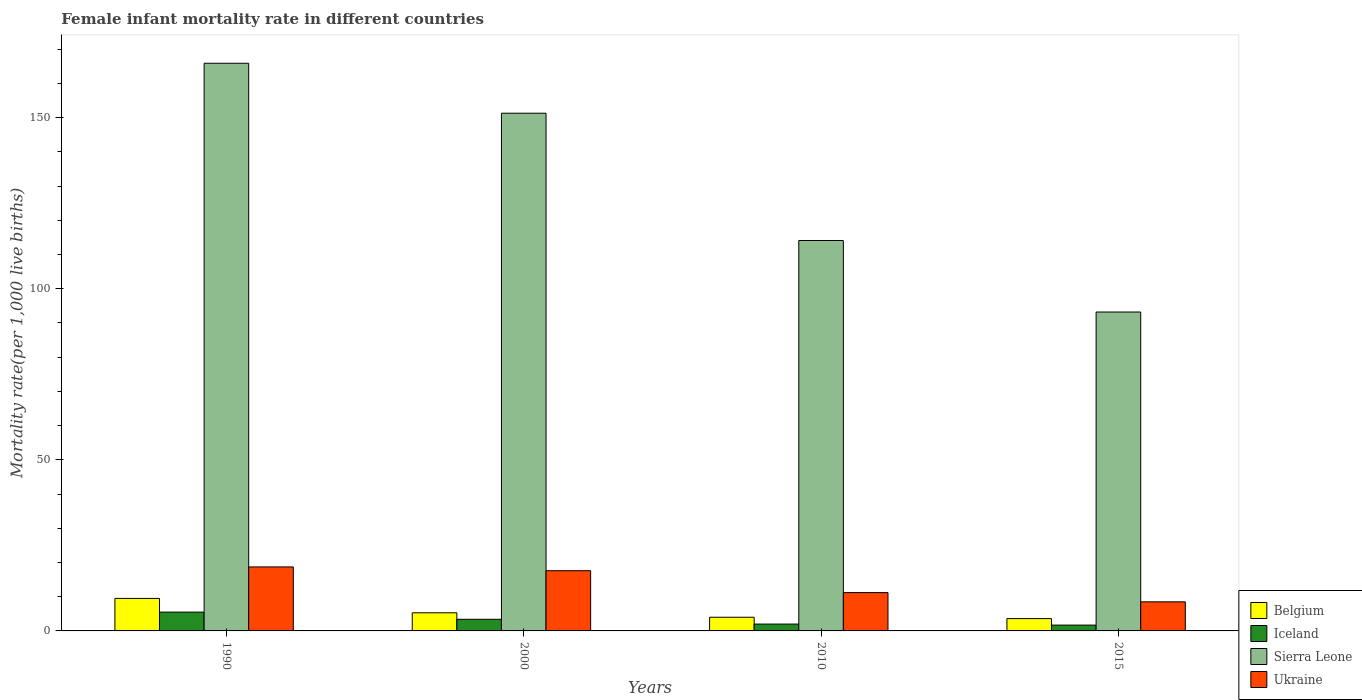How many groups of bars are there?
Make the answer very short. 4. Are the number of bars per tick equal to the number of legend labels?
Make the answer very short. Yes. Are the number of bars on each tick of the X-axis equal?
Your answer should be compact. Yes. How many bars are there on the 3rd tick from the right?
Give a very brief answer. 4. In which year was the female infant mortality rate in Sierra Leone minimum?
Your answer should be very brief. 2015. What is the total female infant mortality rate in Belgium in the graph?
Give a very brief answer. 22.4. What is the difference between the female infant mortality rate in Ukraine in 2000 and that in 2010?
Ensure brevity in your answer.  6.4. What is the difference between the female infant mortality rate in Sierra Leone in 2010 and the female infant mortality rate in Belgium in 2015?
Make the answer very short. 110.5. What is the average female infant mortality rate in Belgium per year?
Your response must be concise. 5.6. What is the ratio of the female infant mortality rate in Belgium in 1990 to that in 2015?
Make the answer very short. 2.64. Is the female infant mortality rate in Ukraine in 2000 less than that in 2015?
Offer a very short reply. No. What is the difference between the highest and the second highest female infant mortality rate in Sierra Leone?
Provide a short and direct response. 14.6. What is the difference between the highest and the lowest female infant mortality rate in Ukraine?
Ensure brevity in your answer.  10.2. Is it the case that in every year, the sum of the female infant mortality rate in Iceland and female infant mortality rate in Sierra Leone is greater than the sum of female infant mortality rate in Ukraine and female infant mortality rate in Belgium?
Provide a succinct answer. Yes. What does the 3rd bar from the left in 2015 represents?
Give a very brief answer. Sierra Leone. What does the 3rd bar from the right in 2015 represents?
Ensure brevity in your answer.  Iceland. Are all the bars in the graph horizontal?
Provide a short and direct response. No. What is the difference between two consecutive major ticks on the Y-axis?
Provide a succinct answer. 50. Are the values on the major ticks of Y-axis written in scientific E-notation?
Ensure brevity in your answer.  No. Does the graph contain any zero values?
Offer a very short reply. No. What is the title of the graph?
Make the answer very short. Female infant mortality rate in different countries. What is the label or title of the X-axis?
Keep it short and to the point. Years. What is the label or title of the Y-axis?
Provide a short and direct response. Mortality rate(per 1,0 live births). What is the Mortality rate(per 1,000 live births) of Iceland in 1990?
Offer a very short reply. 5.5. What is the Mortality rate(per 1,000 live births) of Sierra Leone in 1990?
Your answer should be very brief. 165.9. What is the Mortality rate(per 1,000 live births) of Belgium in 2000?
Your response must be concise. 5.3. What is the Mortality rate(per 1,000 live births) in Iceland in 2000?
Offer a very short reply. 3.4. What is the Mortality rate(per 1,000 live births) in Sierra Leone in 2000?
Your response must be concise. 151.3. What is the Mortality rate(per 1,000 live births) in Iceland in 2010?
Provide a succinct answer. 2. What is the Mortality rate(per 1,000 live births) in Sierra Leone in 2010?
Provide a succinct answer. 114.1. What is the Mortality rate(per 1,000 live births) in Ukraine in 2010?
Offer a terse response. 11.2. What is the Mortality rate(per 1,000 live births) of Sierra Leone in 2015?
Your answer should be very brief. 93.2. What is the Mortality rate(per 1,000 live births) of Ukraine in 2015?
Your answer should be compact. 8.5. Across all years, what is the maximum Mortality rate(per 1,000 live births) in Sierra Leone?
Make the answer very short. 165.9. Across all years, what is the maximum Mortality rate(per 1,000 live births) in Ukraine?
Your answer should be compact. 18.7. Across all years, what is the minimum Mortality rate(per 1,000 live births) of Iceland?
Offer a very short reply. 1.7. Across all years, what is the minimum Mortality rate(per 1,000 live births) of Sierra Leone?
Your answer should be very brief. 93.2. What is the total Mortality rate(per 1,000 live births) in Belgium in the graph?
Your answer should be compact. 22.4. What is the total Mortality rate(per 1,000 live births) in Iceland in the graph?
Ensure brevity in your answer.  12.6. What is the total Mortality rate(per 1,000 live births) of Sierra Leone in the graph?
Offer a terse response. 524.5. What is the difference between the Mortality rate(per 1,000 live births) of Iceland in 1990 and that in 2000?
Offer a terse response. 2.1. What is the difference between the Mortality rate(per 1,000 live births) in Sierra Leone in 1990 and that in 2000?
Make the answer very short. 14.6. What is the difference between the Mortality rate(per 1,000 live births) of Ukraine in 1990 and that in 2000?
Your answer should be compact. 1.1. What is the difference between the Mortality rate(per 1,000 live births) in Iceland in 1990 and that in 2010?
Your answer should be compact. 3.5. What is the difference between the Mortality rate(per 1,000 live births) of Sierra Leone in 1990 and that in 2010?
Ensure brevity in your answer.  51.8. What is the difference between the Mortality rate(per 1,000 live births) of Belgium in 1990 and that in 2015?
Provide a short and direct response. 5.9. What is the difference between the Mortality rate(per 1,000 live births) of Sierra Leone in 1990 and that in 2015?
Make the answer very short. 72.7. What is the difference between the Mortality rate(per 1,000 live births) in Belgium in 2000 and that in 2010?
Give a very brief answer. 1.3. What is the difference between the Mortality rate(per 1,000 live births) in Sierra Leone in 2000 and that in 2010?
Your answer should be very brief. 37.2. What is the difference between the Mortality rate(per 1,000 live births) of Ukraine in 2000 and that in 2010?
Make the answer very short. 6.4. What is the difference between the Mortality rate(per 1,000 live births) of Iceland in 2000 and that in 2015?
Offer a terse response. 1.7. What is the difference between the Mortality rate(per 1,000 live births) in Sierra Leone in 2000 and that in 2015?
Provide a succinct answer. 58.1. What is the difference between the Mortality rate(per 1,000 live births) in Ukraine in 2000 and that in 2015?
Your answer should be compact. 9.1. What is the difference between the Mortality rate(per 1,000 live births) of Sierra Leone in 2010 and that in 2015?
Ensure brevity in your answer.  20.9. What is the difference between the Mortality rate(per 1,000 live births) of Belgium in 1990 and the Mortality rate(per 1,000 live births) of Iceland in 2000?
Provide a short and direct response. 6.1. What is the difference between the Mortality rate(per 1,000 live births) of Belgium in 1990 and the Mortality rate(per 1,000 live births) of Sierra Leone in 2000?
Ensure brevity in your answer.  -141.8. What is the difference between the Mortality rate(per 1,000 live births) of Iceland in 1990 and the Mortality rate(per 1,000 live births) of Sierra Leone in 2000?
Keep it short and to the point. -145.8. What is the difference between the Mortality rate(per 1,000 live births) of Iceland in 1990 and the Mortality rate(per 1,000 live births) of Ukraine in 2000?
Make the answer very short. -12.1. What is the difference between the Mortality rate(per 1,000 live births) of Sierra Leone in 1990 and the Mortality rate(per 1,000 live births) of Ukraine in 2000?
Give a very brief answer. 148.3. What is the difference between the Mortality rate(per 1,000 live births) in Belgium in 1990 and the Mortality rate(per 1,000 live births) in Iceland in 2010?
Offer a terse response. 7.5. What is the difference between the Mortality rate(per 1,000 live births) of Belgium in 1990 and the Mortality rate(per 1,000 live births) of Sierra Leone in 2010?
Make the answer very short. -104.6. What is the difference between the Mortality rate(per 1,000 live births) in Belgium in 1990 and the Mortality rate(per 1,000 live births) in Ukraine in 2010?
Offer a very short reply. -1.7. What is the difference between the Mortality rate(per 1,000 live births) of Iceland in 1990 and the Mortality rate(per 1,000 live births) of Sierra Leone in 2010?
Make the answer very short. -108.6. What is the difference between the Mortality rate(per 1,000 live births) of Iceland in 1990 and the Mortality rate(per 1,000 live births) of Ukraine in 2010?
Provide a short and direct response. -5.7. What is the difference between the Mortality rate(per 1,000 live births) of Sierra Leone in 1990 and the Mortality rate(per 1,000 live births) of Ukraine in 2010?
Offer a very short reply. 154.7. What is the difference between the Mortality rate(per 1,000 live births) in Belgium in 1990 and the Mortality rate(per 1,000 live births) in Iceland in 2015?
Your answer should be compact. 7.8. What is the difference between the Mortality rate(per 1,000 live births) of Belgium in 1990 and the Mortality rate(per 1,000 live births) of Sierra Leone in 2015?
Your answer should be very brief. -83.7. What is the difference between the Mortality rate(per 1,000 live births) in Iceland in 1990 and the Mortality rate(per 1,000 live births) in Sierra Leone in 2015?
Make the answer very short. -87.7. What is the difference between the Mortality rate(per 1,000 live births) of Sierra Leone in 1990 and the Mortality rate(per 1,000 live births) of Ukraine in 2015?
Your response must be concise. 157.4. What is the difference between the Mortality rate(per 1,000 live births) of Belgium in 2000 and the Mortality rate(per 1,000 live births) of Iceland in 2010?
Your response must be concise. 3.3. What is the difference between the Mortality rate(per 1,000 live births) of Belgium in 2000 and the Mortality rate(per 1,000 live births) of Sierra Leone in 2010?
Your response must be concise. -108.8. What is the difference between the Mortality rate(per 1,000 live births) in Iceland in 2000 and the Mortality rate(per 1,000 live births) in Sierra Leone in 2010?
Offer a very short reply. -110.7. What is the difference between the Mortality rate(per 1,000 live births) of Iceland in 2000 and the Mortality rate(per 1,000 live births) of Ukraine in 2010?
Your answer should be compact. -7.8. What is the difference between the Mortality rate(per 1,000 live births) in Sierra Leone in 2000 and the Mortality rate(per 1,000 live births) in Ukraine in 2010?
Offer a terse response. 140.1. What is the difference between the Mortality rate(per 1,000 live births) of Belgium in 2000 and the Mortality rate(per 1,000 live births) of Sierra Leone in 2015?
Provide a succinct answer. -87.9. What is the difference between the Mortality rate(per 1,000 live births) in Iceland in 2000 and the Mortality rate(per 1,000 live births) in Sierra Leone in 2015?
Keep it short and to the point. -89.8. What is the difference between the Mortality rate(per 1,000 live births) of Iceland in 2000 and the Mortality rate(per 1,000 live births) of Ukraine in 2015?
Ensure brevity in your answer.  -5.1. What is the difference between the Mortality rate(per 1,000 live births) of Sierra Leone in 2000 and the Mortality rate(per 1,000 live births) of Ukraine in 2015?
Offer a terse response. 142.8. What is the difference between the Mortality rate(per 1,000 live births) in Belgium in 2010 and the Mortality rate(per 1,000 live births) in Sierra Leone in 2015?
Provide a short and direct response. -89.2. What is the difference between the Mortality rate(per 1,000 live births) in Belgium in 2010 and the Mortality rate(per 1,000 live births) in Ukraine in 2015?
Make the answer very short. -4.5. What is the difference between the Mortality rate(per 1,000 live births) of Iceland in 2010 and the Mortality rate(per 1,000 live births) of Sierra Leone in 2015?
Offer a very short reply. -91.2. What is the difference between the Mortality rate(per 1,000 live births) of Iceland in 2010 and the Mortality rate(per 1,000 live births) of Ukraine in 2015?
Keep it short and to the point. -6.5. What is the difference between the Mortality rate(per 1,000 live births) in Sierra Leone in 2010 and the Mortality rate(per 1,000 live births) in Ukraine in 2015?
Provide a short and direct response. 105.6. What is the average Mortality rate(per 1,000 live births) of Belgium per year?
Provide a short and direct response. 5.6. What is the average Mortality rate(per 1,000 live births) of Iceland per year?
Your answer should be compact. 3.15. What is the average Mortality rate(per 1,000 live births) of Sierra Leone per year?
Your answer should be very brief. 131.12. What is the average Mortality rate(per 1,000 live births) in Ukraine per year?
Offer a terse response. 14. In the year 1990, what is the difference between the Mortality rate(per 1,000 live births) of Belgium and Mortality rate(per 1,000 live births) of Iceland?
Your answer should be very brief. 4. In the year 1990, what is the difference between the Mortality rate(per 1,000 live births) of Belgium and Mortality rate(per 1,000 live births) of Sierra Leone?
Keep it short and to the point. -156.4. In the year 1990, what is the difference between the Mortality rate(per 1,000 live births) in Iceland and Mortality rate(per 1,000 live births) in Sierra Leone?
Provide a short and direct response. -160.4. In the year 1990, what is the difference between the Mortality rate(per 1,000 live births) of Iceland and Mortality rate(per 1,000 live births) of Ukraine?
Your answer should be compact. -13.2. In the year 1990, what is the difference between the Mortality rate(per 1,000 live births) of Sierra Leone and Mortality rate(per 1,000 live births) of Ukraine?
Offer a terse response. 147.2. In the year 2000, what is the difference between the Mortality rate(per 1,000 live births) of Belgium and Mortality rate(per 1,000 live births) of Iceland?
Provide a succinct answer. 1.9. In the year 2000, what is the difference between the Mortality rate(per 1,000 live births) in Belgium and Mortality rate(per 1,000 live births) in Sierra Leone?
Provide a succinct answer. -146. In the year 2000, what is the difference between the Mortality rate(per 1,000 live births) in Belgium and Mortality rate(per 1,000 live births) in Ukraine?
Ensure brevity in your answer.  -12.3. In the year 2000, what is the difference between the Mortality rate(per 1,000 live births) of Iceland and Mortality rate(per 1,000 live births) of Sierra Leone?
Your answer should be compact. -147.9. In the year 2000, what is the difference between the Mortality rate(per 1,000 live births) of Iceland and Mortality rate(per 1,000 live births) of Ukraine?
Offer a terse response. -14.2. In the year 2000, what is the difference between the Mortality rate(per 1,000 live births) in Sierra Leone and Mortality rate(per 1,000 live births) in Ukraine?
Give a very brief answer. 133.7. In the year 2010, what is the difference between the Mortality rate(per 1,000 live births) of Belgium and Mortality rate(per 1,000 live births) of Iceland?
Provide a succinct answer. 2. In the year 2010, what is the difference between the Mortality rate(per 1,000 live births) in Belgium and Mortality rate(per 1,000 live births) in Sierra Leone?
Your answer should be very brief. -110.1. In the year 2010, what is the difference between the Mortality rate(per 1,000 live births) in Belgium and Mortality rate(per 1,000 live births) in Ukraine?
Offer a very short reply. -7.2. In the year 2010, what is the difference between the Mortality rate(per 1,000 live births) in Iceland and Mortality rate(per 1,000 live births) in Sierra Leone?
Offer a terse response. -112.1. In the year 2010, what is the difference between the Mortality rate(per 1,000 live births) of Iceland and Mortality rate(per 1,000 live births) of Ukraine?
Your answer should be very brief. -9.2. In the year 2010, what is the difference between the Mortality rate(per 1,000 live births) in Sierra Leone and Mortality rate(per 1,000 live births) in Ukraine?
Ensure brevity in your answer.  102.9. In the year 2015, what is the difference between the Mortality rate(per 1,000 live births) of Belgium and Mortality rate(per 1,000 live births) of Sierra Leone?
Keep it short and to the point. -89.6. In the year 2015, what is the difference between the Mortality rate(per 1,000 live births) in Iceland and Mortality rate(per 1,000 live births) in Sierra Leone?
Offer a terse response. -91.5. In the year 2015, what is the difference between the Mortality rate(per 1,000 live births) of Iceland and Mortality rate(per 1,000 live births) of Ukraine?
Ensure brevity in your answer.  -6.8. In the year 2015, what is the difference between the Mortality rate(per 1,000 live births) of Sierra Leone and Mortality rate(per 1,000 live births) of Ukraine?
Keep it short and to the point. 84.7. What is the ratio of the Mortality rate(per 1,000 live births) in Belgium in 1990 to that in 2000?
Keep it short and to the point. 1.79. What is the ratio of the Mortality rate(per 1,000 live births) in Iceland in 1990 to that in 2000?
Offer a terse response. 1.62. What is the ratio of the Mortality rate(per 1,000 live births) in Sierra Leone in 1990 to that in 2000?
Give a very brief answer. 1.1. What is the ratio of the Mortality rate(per 1,000 live births) of Belgium in 1990 to that in 2010?
Offer a terse response. 2.38. What is the ratio of the Mortality rate(per 1,000 live births) of Iceland in 1990 to that in 2010?
Keep it short and to the point. 2.75. What is the ratio of the Mortality rate(per 1,000 live births) in Sierra Leone in 1990 to that in 2010?
Keep it short and to the point. 1.45. What is the ratio of the Mortality rate(per 1,000 live births) of Ukraine in 1990 to that in 2010?
Make the answer very short. 1.67. What is the ratio of the Mortality rate(per 1,000 live births) of Belgium in 1990 to that in 2015?
Keep it short and to the point. 2.64. What is the ratio of the Mortality rate(per 1,000 live births) in Iceland in 1990 to that in 2015?
Make the answer very short. 3.24. What is the ratio of the Mortality rate(per 1,000 live births) in Sierra Leone in 1990 to that in 2015?
Your answer should be very brief. 1.78. What is the ratio of the Mortality rate(per 1,000 live births) in Belgium in 2000 to that in 2010?
Make the answer very short. 1.32. What is the ratio of the Mortality rate(per 1,000 live births) of Iceland in 2000 to that in 2010?
Your answer should be compact. 1.7. What is the ratio of the Mortality rate(per 1,000 live births) of Sierra Leone in 2000 to that in 2010?
Give a very brief answer. 1.33. What is the ratio of the Mortality rate(per 1,000 live births) in Ukraine in 2000 to that in 2010?
Provide a short and direct response. 1.57. What is the ratio of the Mortality rate(per 1,000 live births) in Belgium in 2000 to that in 2015?
Offer a very short reply. 1.47. What is the ratio of the Mortality rate(per 1,000 live births) in Sierra Leone in 2000 to that in 2015?
Ensure brevity in your answer.  1.62. What is the ratio of the Mortality rate(per 1,000 live births) of Ukraine in 2000 to that in 2015?
Your answer should be very brief. 2.07. What is the ratio of the Mortality rate(per 1,000 live births) of Belgium in 2010 to that in 2015?
Provide a succinct answer. 1.11. What is the ratio of the Mortality rate(per 1,000 live births) in Iceland in 2010 to that in 2015?
Ensure brevity in your answer.  1.18. What is the ratio of the Mortality rate(per 1,000 live births) of Sierra Leone in 2010 to that in 2015?
Provide a succinct answer. 1.22. What is the ratio of the Mortality rate(per 1,000 live births) of Ukraine in 2010 to that in 2015?
Your answer should be compact. 1.32. What is the difference between the highest and the second highest Mortality rate(per 1,000 live births) of Iceland?
Make the answer very short. 2.1. What is the difference between the highest and the second highest Mortality rate(per 1,000 live births) in Sierra Leone?
Your answer should be very brief. 14.6. What is the difference between the highest and the second highest Mortality rate(per 1,000 live births) of Ukraine?
Your answer should be compact. 1.1. What is the difference between the highest and the lowest Mortality rate(per 1,000 live births) of Belgium?
Your answer should be compact. 5.9. What is the difference between the highest and the lowest Mortality rate(per 1,000 live births) in Sierra Leone?
Provide a succinct answer. 72.7. What is the difference between the highest and the lowest Mortality rate(per 1,000 live births) of Ukraine?
Ensure brevity in your answer.  10.2. 